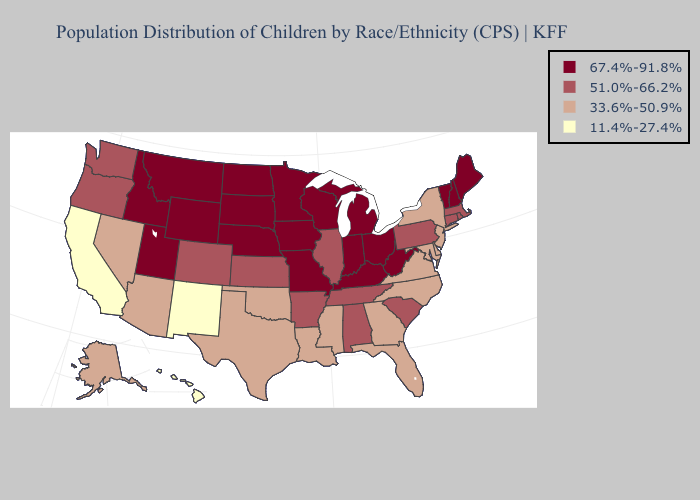Does New Mexico have the lowest value in the USA?
Write a very short answer. Yes. What is the lowest value in the Northeast?
Give a very brief answer. 33.6%-50.9%. Does Rhode Island have the highest value in the USA?
Short answer required. No. Name the states that have a value in the range 51.0%-66.2%?
Be succinct. Alabama, Arkansas, Colorado, Connecticut, Illinois, Kansas, Massachusetts, Oregon, Pennsylvania, Rhode Island, South Carolina, Tennessee, Washington. Name the states that have a value in the range 67.4%-91.8%?
Keep it brief. Idaho, Indiana, Iowa, Kentucky, Maine, Michigan, Minnesota, Missouri, Montana, Nebraska, New Hampshire, North Dakota, Ohio, South Dakota, Utah, Vermont, West Virginia, Wisconsin, Wyoming. Among the states that border South Carolina , which have the highest value?
Quick response, please. Georgia, North Carolina. What is the value of Virginia?
Write a very short answer. 33.6%-50.9%. Which states have the lowest value in the West?
Give a very brief answer. California, Hawaii, New Mexico. What is the value of Mississippi?
Keep it brief. 33.6%-50.9%. Among the states that border Oregon , which have the lowest value?
Concise answer only. California. Name the states that have a value in the range 11.4%-27.4%?
Short answer required. California, Hawaii, New Mexico. Name the states that have a value in the range 51.0%-66.2%?
Quick response, please. Alabama, Arkansas, Colorado, Connecticut, Illinois, Kansas, Massachusetts, Oregon, Pennsylvania, Rhode Island, South Carolina, Tennessee, Washington. Does Georgia have the highest value in the South?
Answer briefly. No. Does Virginia have a lower value than New Mexico?
Short answer required. No. Name the states that have a value in the range 51.0%-66.2%?
Be succinct. Alabama, Arkansas, Colorado, Connecticut, Illinois, Kansas, Massachusetts, Oregon, Pennsylvania, Rhode Island, South Carolina, Tennessee, Washington. 